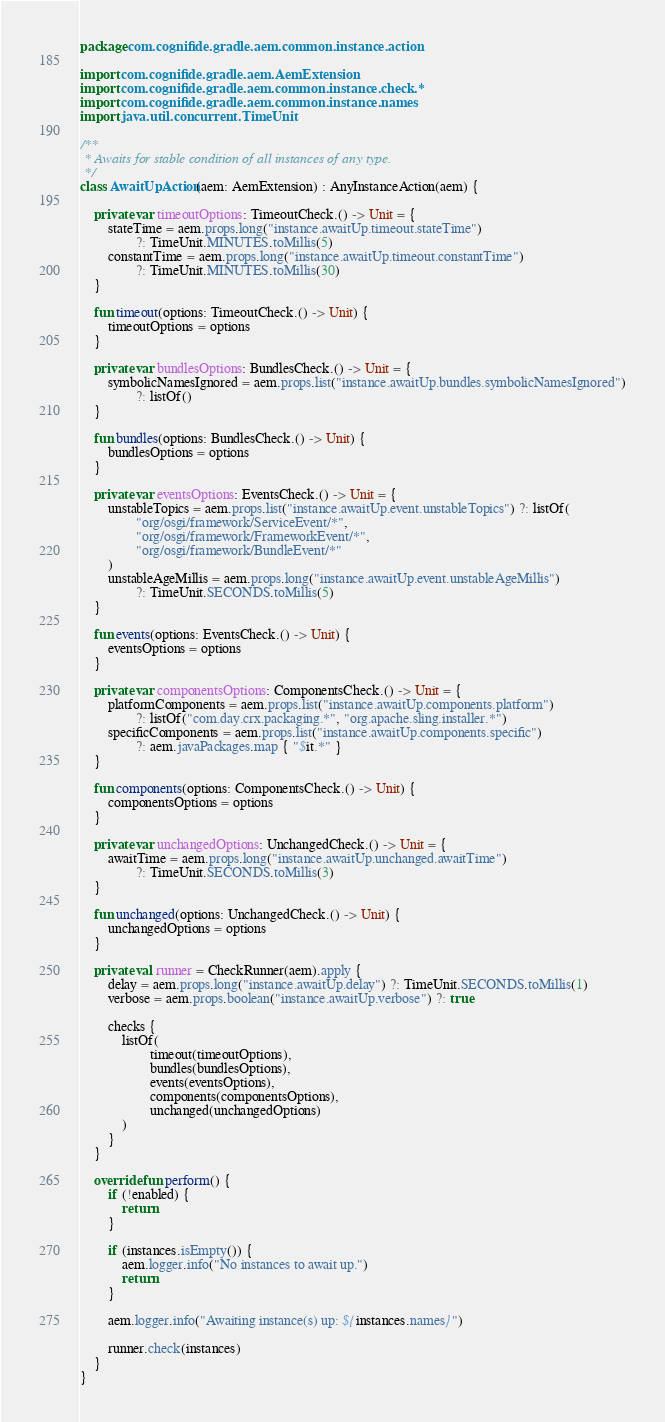<code> <loc_0><loc_0><loc_500><loc_500><_Kotlin_>package com.cognifide.gradle.aem.common.instance.action

import com.cognifide.gradle.aem.AemExtension
import com.cognifide.gradle.aem.common.instance.check.*
import com.cognifide.gradle.aem.common.instance.names
import java.util.concurrent.TimeUnit

/**
 * Awaits for stable condition of all instances of any type.
 */
class AwaitUpAction(aem: AemExtension) : AnyInstanceAction(aem) {

    private var timeoutOptions: TimeoutCheck.() -> Unit = {
        stateTime = aem.props.long("instance.awaitUp.timeout.stateTime")
                ?: TimeUnit.MINUTES.toMillis(5)
        constantTime = aem.props.long("instance.awaitUp.timeout.constantTime")
                ?: TimeUnit.MINUTES.toMillis(30)
    }

    fun timeout(options: TimeoutCheck.() -> Unit) {
        timeoutOptions = options
    }

    private var bundlesOptions: BundlesCheck.() -> Unit = {
        symbolicNamesIgnored = aem.props.list("instance.awaitUp.bundles.symbolicNamesIgnored")
                ?: listOf()
    }

    fun bundles(options: BundlesCheck.() -> Unit) {
        bundlesOptions = options
    }

    private var eventsOptions: EventsCheck.() -> Unit = {
        unstableTopics = aem.props.list("instance.awaitUp.event.unstableTopics") ?: listOf(
                "org/osgi/framework/ServiceEvent/*",
                "org/osgi/framework/FrameworkEvent/*",
                "org/osgi/framework/BundleEvent/*"
        )
        unstableAgeMillis = aem.props.long("instance.awaitUp.event.unstableAgeMillis")
                ?: TimeUnit.SECONDS.toMillis(5)
    }

    fun events(options: EventsCheck.() -> Unit) {
        eventsOptions = options
    }

    private var componentsOptions: ComponentsCheck.() -> Unit = {
        platformComponents = aem.props.list("instance.awaitUp.components.platform")
                ?: listOf("com.day.crx.packaging.*", "org.apache.sling.installer.*")
        specificComponents = aem.props.list("instance.awaitUp.components.specific")
                ?: aem.javaPackages.map { "$it.*" }
    }

    fun components(options: ComponentsCheck.() -> Unit) {
        componentsOptions = options
    }

    private var unchangedOptions: UnchangedCheck.() -> Unit = {
        awaitTime = aem.props.long("instance.awaitUp.unchanged.awaitTime")
                ?: TimeUnit.SECONDS.toMillis(3)
    }

    fun unchanged(options: UnchangedCheck.() -> Unit) {
        unchangedOptions = options
    }

    private val runner = CheckRunner(aem).apply {
        delay = aem.props.long("instance.awaitUp.delay") ?: TimeUnit.SECONDS.toMillis(1)
        verbose = aem.props.boolean("instance.awaitUp.verbose") ?: true

        checks {
            listOf(
                    timeout(timeoutOptions),
                    bundles(bundlesOptions),
                    events(eventsOptions),
                    components(componentsOptions),
                    unchanged(unchangedOptions)
            )
        }
    }

    override fun perform() {
        if (!enabled) {
            return
        }

        if (instances.isEmpty()) {
            aem.logger.info("No instances to await up.")
            return
        }

        aem.logger.info("Awaiting instance(s) up: ${instances.names}")

        runner.check(instances)
    }
}</code> 